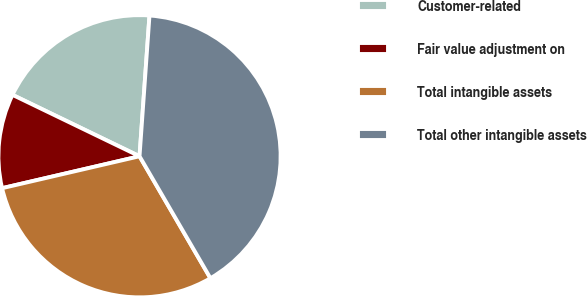Convert chart. <chart><loc_0><loc_0><loc_500><loc_500><pie_chart><fcel>Customer-related<fcel>Fair value adjustment on<fcel>Total intangible assets<fcel>Total other intangible assets<nl><fcel>18.96%<fcel>10.8%<fcel>29.75%<fcel>40.5%<nl></chart> 